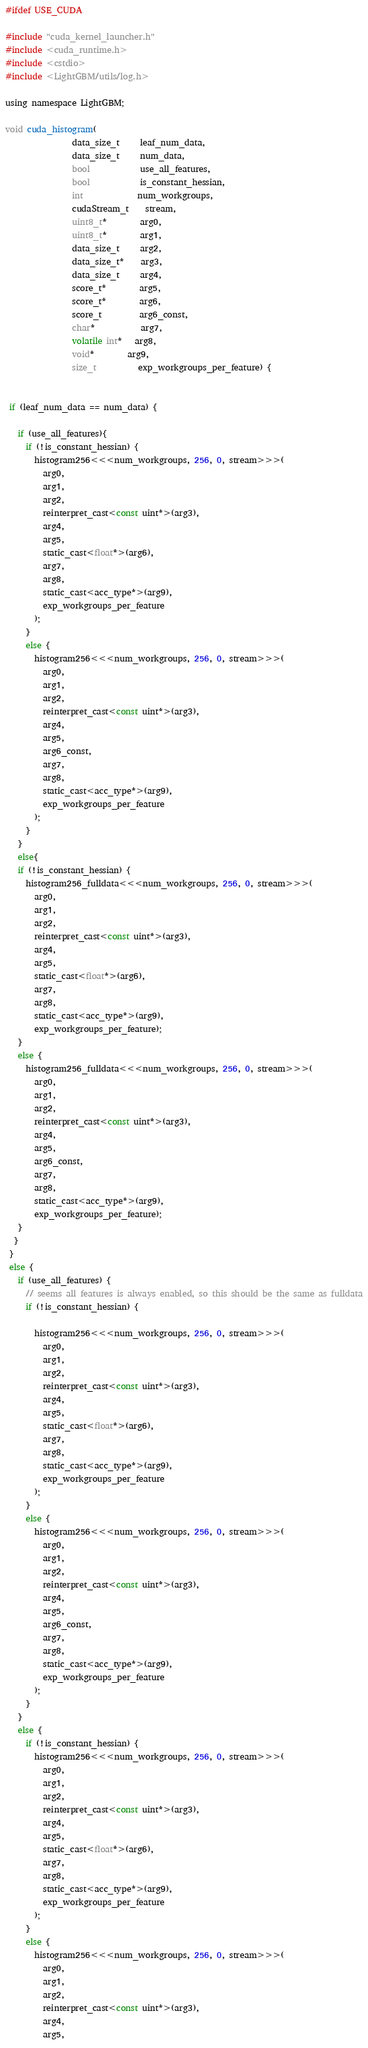Convert code to text. <code><loc_0><loc_0><loc_500><loc_500><_Cuda_>#ifdef USE_CUDA

#include "cuda_kernel_launcher.h"
#include <cuda_runtime.h>
#include <cstdio>
#include <LightGBM/utils/log.h>

using namespace LightGBM;

void cuda_histogram(
                data_size_t     leaf_num_data,
                data_size_t     num_data,
                bool            use_all_features,
                bool            is_constant_hessian,
                int             num_workgroups,
                cudaStream_t    stream,
                uint8_t*        arg0,
                uint8_t*        arg1,
                data_size_t     arg2,
                data_size_t*    arg3,
                data_size_t     arg4,
                score_t*        arg5,
                score_t*        arg6,
                score_t         arg6_const,
                char*           arg7,
                volatile int*   arg8,
                void*		arg9,
                size_t          exp_workgroups_per_feature) {


 if (leaf_num_data == num_data) {
 
   if (use_all_features){
     if (!is_constant_hessian) {
       histogram256<<<num_workgroups, 256, 0, stream>>>(
         arg0,
         arg1,
         arg2,
         reinterpret_cast<const uint*>(arg3),
         arg4,
         arg5,
         static_cast<float*>(arg6),
         arg7,
         arg8,
         static_cast<acc_type*>(arg9),
         exp_workgroups_per_feature
       );
     }
     else {
       histogram256<<<num_workgroups, 256, 0, stream>>>(
         arg0,
         arg1,
         arg2,
         reinterpret_cast<const uint*>(arg3),
         arg4,
         arg5,
         arg6_const,
         arg7,
         arg8,
         static_cast<acc_type*>(arg9),
         exp_workgroups_per_feature
       );
     }
   }
   else{   
   if (!is_constant_hessian) { 
     histogram256_fulldata<<<num_workgroups, 256, 0, stream>>>(
       arg0,
       arg1,
       arg2,
       reinterpret_cast<const uint*>(arg3),
       arg4,
       arg5,
       static_cast<float*>(arg6),
       arg7,
       arg8,
       static_cast<acc_type*>(arg9),
       exp_workgroups_per_feature);
   }
   else { 
     histogram256_fulldata<<<num_workgroups, 256, 0, stream>>>(
       arg0,
       arg1,
       arg2,
       reinterpret_cast<const uint*>(arg3),
       arg4,
       arg5,
       arg6_const, 
       arg7,
       arg8,
       static_cast<acc_type*>(arg9),
       exp_workgroups_per_feature);
   }
  }
 }
 else {
   if (use_all_features) {
     // seems all features is always enabled, so this should be the same as fulldata
     if (!is_constant_hessian) { 

       histogram256<<<num_workgroups, 256, 0, stream>>>(
         arg0,
         arg1,
         arg2,
         reinterpret_cast<const uint*>(arg3),
         arg4,
         arg5,
         static_cast<float*>(arg6),
         arg7,
         arg8,
         static_cast<acc_type*>(arg9),
         exp_workgroups_per_feature
       );
     }
     else { 
       histogram256<<<num_workgroups, 256, 0, stream>>>(
         arg0,
         arg1,
         arg2,
         reinterpret_cast<const uint*>(arg3),
         arg4,
         arg5,
         arg6_const, 
         arg7,
         arg8,
         static_cast<acc_type*>(arg9),
         exp_workgroups_per_feature
       );
     } 
   }
   else {
     if (!is_constant_hessian) { 
       histogram256<<<num_workgroups, 256, 0, stream>>>(
         arg0,
         arg1,
         arg2,
         reinterpret_cast<const uint*>(arg3),
         arg4,
         arg5,
         static_cast<float*>(arg6),
         arg7,
         arg8,
         static_cast<acc_type*>(arg9),
         exp_workgroups_per_feature
       );
     }
     else { 
       histogram256<<<num_workgroups, 256, 0, stream>>>(
         arg0,
         arg1,
         arg2,
         reinterpret_cast<const uint*>(arg3),
         arg4,
         arg5,</code> 